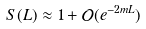<formula> <loc_0><loc_0><loc_500><loc_500>S ( L ) \approx 1 + \mathcal { O } ( e ^ { - 2 m L } )</formula> 